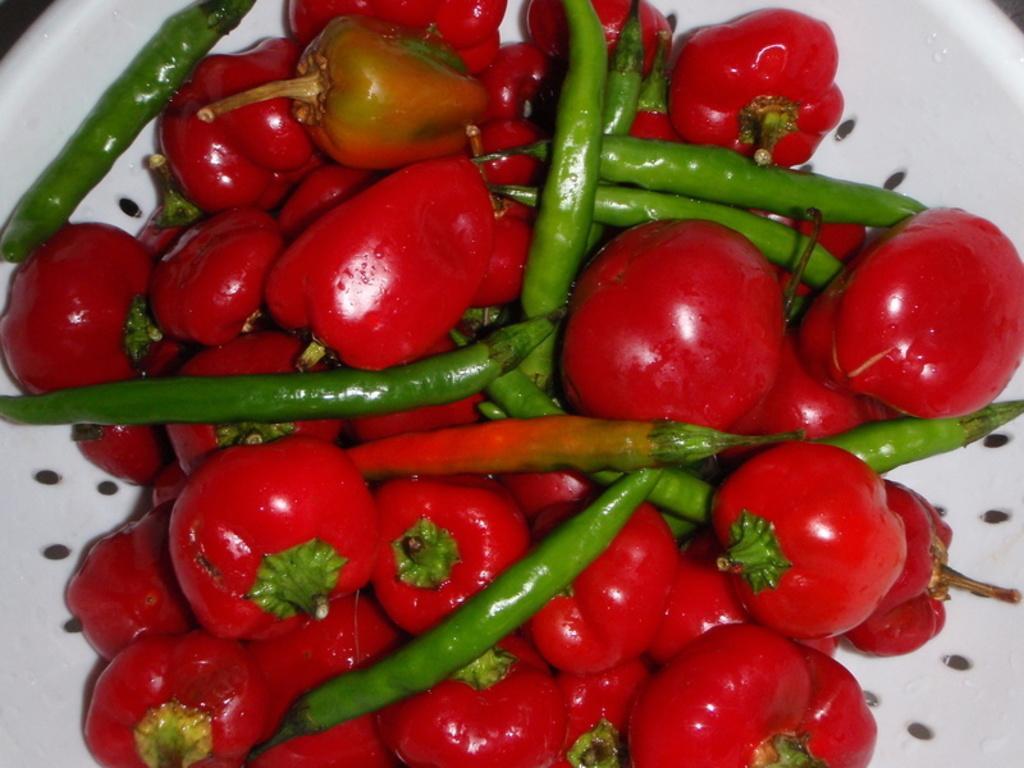Could you give a brief overview of what you see in this image? In this image, we can see red chillies and green chillies in the bowl. 